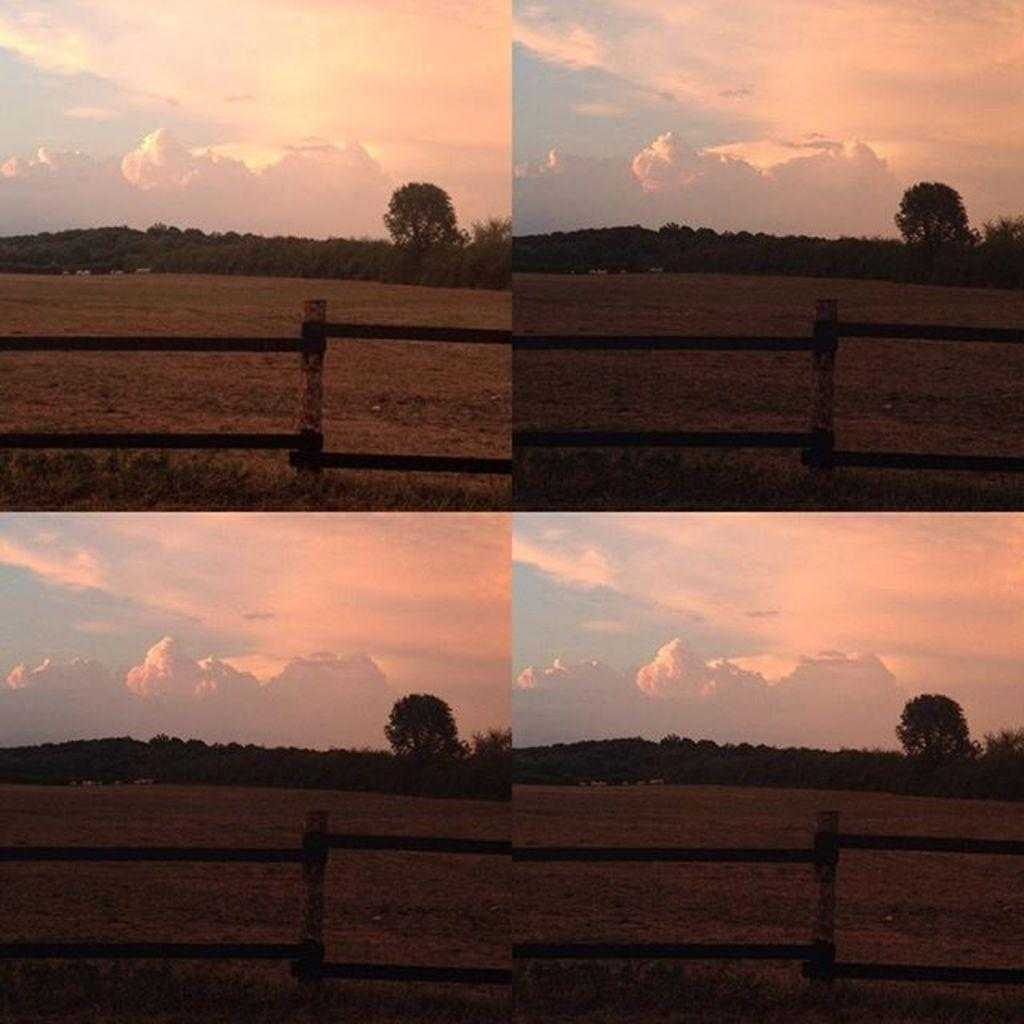What type of artwork is the image? The image is a collage. Where are the dark images located in the collage? The dark images are on the right side of the collage. What elements can be found in the dark images? The dark images contain trees, a wooden fence, grass, and a cloudy sky. What type of net is being used for writing on the linen in the image? There is no net or linen present in the image; it is a collage featuring dark images with trees, a wooden fence, grass, and a cloudy sky. 